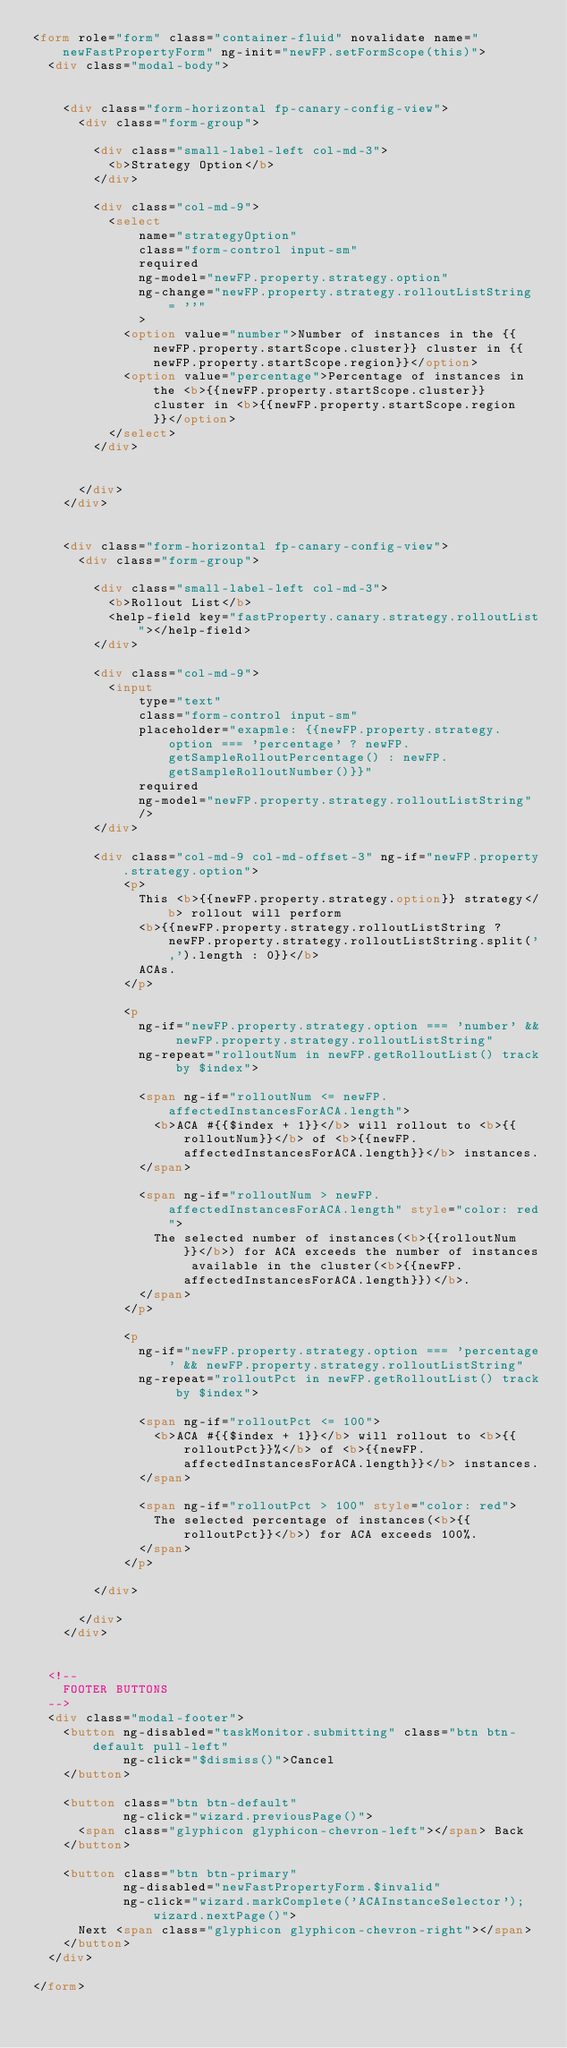<code> <loc_0><loc_0><loc_500><loc_500><_HTML_><form role="form" class="container-fluid" novalidate name="newFastPropertyForm" ng-init="newFP.setFormScope(this)">
  <div class="modal-body">


    <div class="form-horizontal fp-canary-config-view">
      <div class="form-group">

        <div class="small-label-left col-md-3">
          <b>Strategy Option</b>
        </div>

        <div class="col-md-9">
          <select 
              name="strategyOption"
              class="form-control input-sm"
              required
              ng-model="newFP.property.strategy.option"
              ng-change="newFP.property.strategy.rolloutListString = ''"
              >
            <option value="number">Number of instances in the {{newFP.property.startScope.cluster}} cluster in {{newFP.property.startScope.region}}</option>
            <option value="percentage">Percentage of instances in the <b>{{newFP.property.startScope.cluster}} cluster in <b>{{newFP.property.startScope.region}}</option>
          </select>
        </div>


      </div>
    </div>


    <div class="form-horizontal fp-canary-config-view">
      <div class="form-group">

        <div class="small-label-left col-md-3">
          <b>Rollout List</b>
          <help-field key="fastProperty.canary.strategy.rolloutList"></help-field>
        </div>

        <div class="col-md-9">
          <input
              type="text"
              class="form-control input-sm"
              placeholder="exapmle: {{newFP.property.strategy.option === 'percentage' ? newFP.getSampleRolloutPercentage() : newFP.getSampleRolloutNumber()}}"
              required
              ng-model="newFP.property.strategy.rolloutListString"
              />
        </div>

        <div class="col-md-9 col-md-offset-3" ng-if="newFP.property.strategy.option">
            <p>
              This <b>{{newFP.property.strategy.option}} strategy</b> rollout will perform
              <b>{{newFP.property.strategy.rolloutListString ? newFP.property.strategy.rolloutListString.split(',').length : 0}}</b>
              ACAs.
            </p>

            <p
              ng-if="newFP.property.strategy.option === 'number' && newFP.property.strategy.rolloutListString"
              ng-repeat="rolloutNum in newFP.getRolloutList() track by $index">

              <span ng-if="rolloutNum <= newFP.affectedInstancesForACA.length">
                <b>ACA #{{$index + 1}}</b> will rollout to <b>{{rolloutNum}}</b> of <b>{{newFP.affectedInstancesForACA.length}}</b> instances.
              </span>

              <span ng-if="rolloutNum > newFP.affectedInstancesForACA.length" style="color: red">
                The selected number of instances(<b>{{rolloutNum}}</b>) for ACA exceeds the number of instances available in the cluster(<b>{{newFP.affectedInstancesForACA.length}})</b>.
              </span>
            </p>

            <p
              ng-if="newFP.property.strategy.option === 'percentage' && newFP.property.strategy.rolloutListString"
              ng-repeat="rolloutPct in newFP.getRolloutList() track by $index">

              <span ng-if="rolloutPct <= 100">
                <b>ACA #{{$index + 1}}</b> will rollout to <b>{{rolloutPct}}%</b> of <b>{{newFP.affectedInstancesForACA.length}}</b> instances.
              </span>

              <span ng-if="rolloutPct > 100" style="color: red">
                The selected percentage of instances(<b>{{rolloutPct}}</b>) for ACA exceeds 100%.
              </span>
            </p>

        </div>

      </div>
    </div>


  <!--
    FOOTER BUTTONS
  -->
  <div class="modal-footer">
    <button ng-disabled="taskMonitor.submitting" class="btn btn-default pull-left"
            ng-click="$dismiss()">Cancel
    </button>

    <button class="btn btn-default"
            ng-click="wizard.previousPage()">
      <span class="glyphicon glyphicon-chevron-left"></span> Back
    </button>

    <button class="btn btn-primary"
            ng-disabled="newFastPropertyForm.$invalid"
            ng-click="wizard.markComplete('ACAInstanceSelector'); wizard.nextPage()">
      Next <span class="glyphicon glyphicon-chevron-right"></span>
    </button>
  </div>

</form></code> 